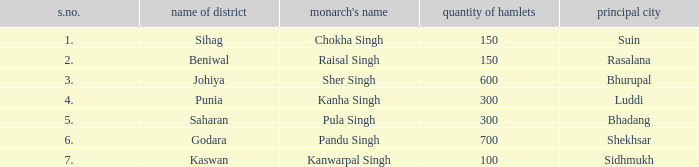Which sovereign has an s. number above 1 and has dominion over 600 villages? Sher Singh. 